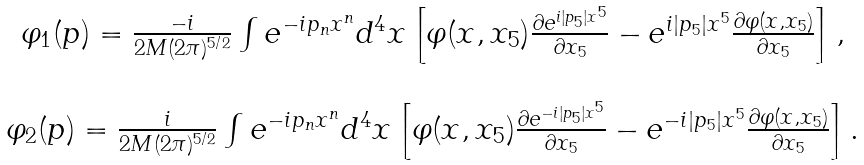<formula> <loc_0><loc_0><loc_500><loc_500>\begin{array} { c } \varphi _ { 1 } ( p ) = \frac { - i } { 2 M ( 2 \pi ) ^ { 5 / 2 } } \int e ^ { - i p _ { n } x ^ { n } } d ^ { 4 } x \left [ \varphi ( x , x _ { 5 } ) \frac { \partial e ^ { i | p _ { 5 } | x ^ { 5 } } } { \partial x _ { 5 } } - e ^ { i | p _ { 5 } | x ^ { 5 } } \frac { \partial \varphi ( x , x _ { 5 } ) } { \partial x _ { 5 } } \right ] , \\ \\ \varphi _ { 2 } ( p ) = \frac { i } { 2 M ( 2 \pi ) ^ { 5 / 2 } } \int e ^ { - i p _ { n } x ^ { n } } d ^ { 4 } x \left [ \varphi ( x , x _ { 5 } ) \frac { \partial e ^ { - i | p _ { 5 } | x ^ { 5 } } } { \partial x _ { 5 } } - e ^ { - i | p _ { 5 } | x ^ { 5 } } \frac { \partial \varphi ( x , x _ { 5 } ) } { \partial x _ { 5 } } \right ] . \\ \end{array}</formula> 